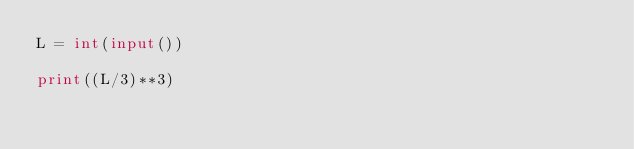<code> <loc_0><loc_0><loc_500><loc_500><_Python_>L = int(input())

print((L/3)**3)
</code> 